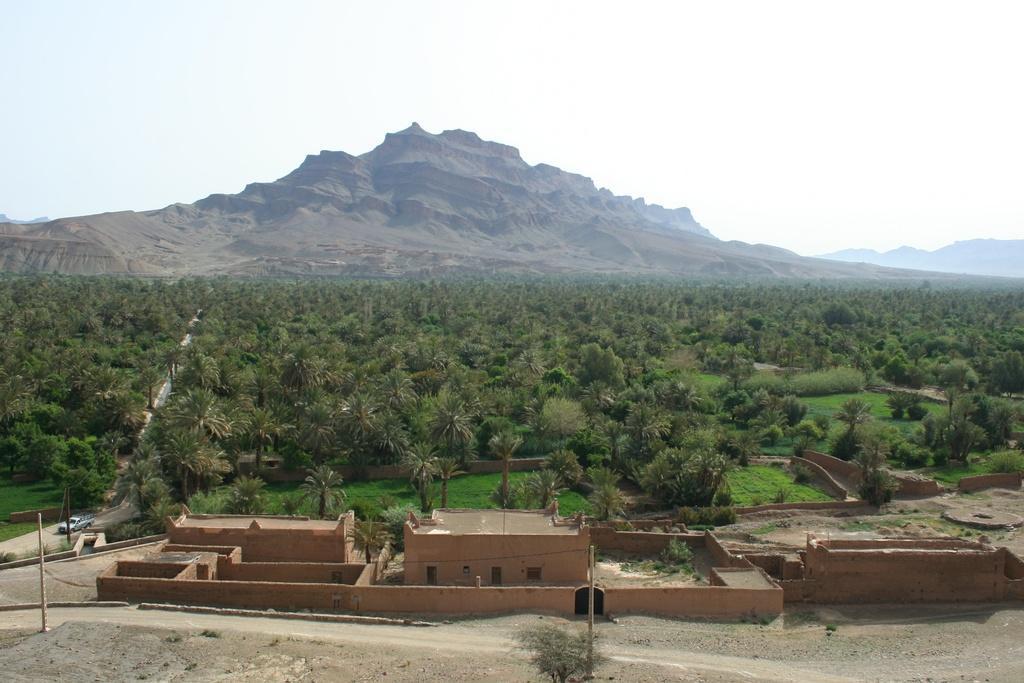Could you give a brief overview of what you see in this image? This image is taken outdoors. At the bottom of the image there is a ground. In the background there are a few hills and there are many plants and trees on the ground. In the middle of the image there is a house with a few walls, windows and doors. A car is moving on the road and there are two poles. 